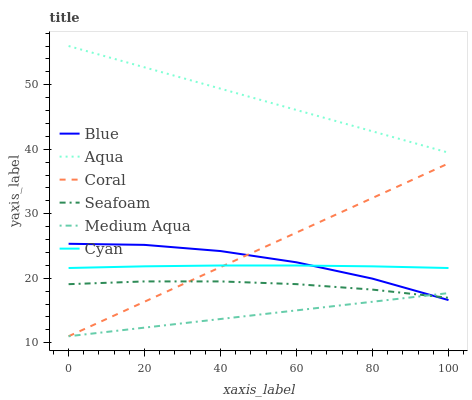Does Medium Aqua have the minimum area under the curve?
Answer yes or no. Yes. Does Aqua have the maximum area under the curve?
Answer yes or no. Yes. Does Coral have the minimum area under the curve?
Answer yes or no. No. Does Coral have the maximum area under the curve?
Answer yes or no. No. Is Aqua the smoothest?
Answer yes or no. Yes. Is Blue the roughest?
Answer yes or no. Yes. Is Coral the smoothest?
Answer yes or no. No. Is Coral the roughest?
Answer yes or no. No. Does Coral have the lowest value?
Answer yes or no. Yes. Does Aqua have the lowest value?
Answer yes or no. No. Does Aqua have the highest value?
Answer yes or no. Yes. Does Coral have the highest value?
Answer yes or no. No. Is Medium Aqua less than Cyan?
Answer yes or no. Yes. Is Aqua greater than Blue?
Answer yes or no. Yes. Does Seafoam intersect Medium Aqua?
Answer yes or no. Yes. Is Seafoam less than Medium Aqua?
Answer yes or no. No. Is Seafoam greater than Medium Aqua?
Answer yes or no. No. Does Medium Aqua intersect Cyan?
Answer yes or no. No. 